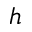Convert formula to latex. <formula><loc_0><loc_0><loc_500><loc_500>h</formula> 